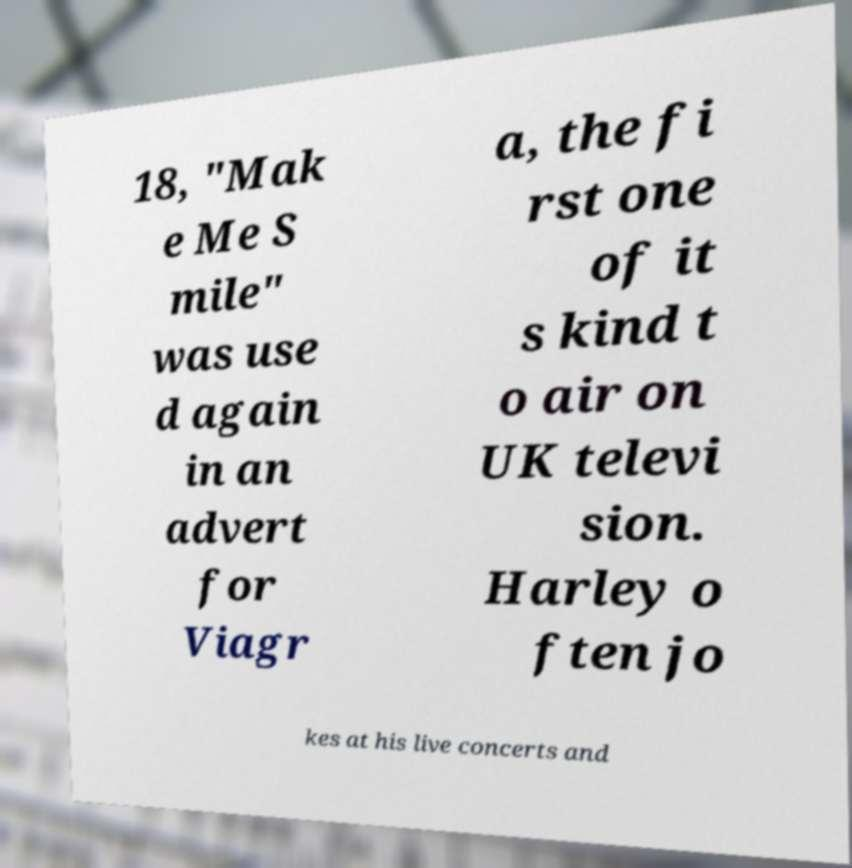Please identify and transcribe the text found in this image. 18, "Mak e Me S mile" was use d again in an advert for Viagr a, the fi rst one of it s kind t o air on UK televi sion. Harley o ften jo kes at his live concerts and 